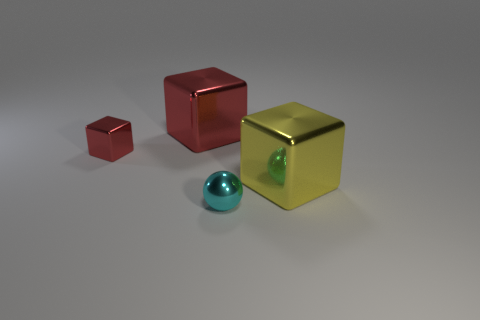What number of other objects are there of the same color as the metal sphere?
Your answer should be compact. 0. Are there any other things that have the same size as the yellow thing?
Your answer should be very brief. Yes. There is a object on the right side of the cyan metal ball; is its size the same as the large red metal thing?
Your answer should be compact. Yes. What is the large block behind the tiny red cube made of?
Give a very brief answer. Metal. Is there anything else that has the same shape as the yellow shiny object?
Offer a very short reply. Yes. What number of rubber objects are either red cylinders or tiny things?
Your answer should be very brief. 0. Are there fewer small shiny cubes that are on the left side of the tiny sphere than cyan spheres?
Your answer should be compact. No. The tiny thing that is to the left of the ball that is to the left of the big thing in front of the tiny red metallic object is what shape?
Provide a short and direct response. Cube. Do the sphere and the tiny block have the same color?
Offer a very short reply. No. Are there more big green things than large yellow things?
Your answer should be very brief. No. 